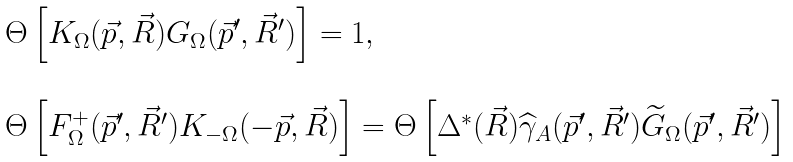<formula> <loc_0><loc_0><loc_500><loc_500>\begin{array} { l } \Theta \left [ K _ { \Omega } ( \vec { p } , \vec { R } ) G _ { \Omega } ( \vec { p } ^ { \prime } , \vec { R } ^ { \prime } ) \right ] = 1 , \\ \\ \Theta \left [ F ^ { + } _ { \Omega } ( \vec { p } ^ { \prime } , \vec { R } ^ { \prime } ) K _ { - \Omega } ( - \vec { p } , \vec { R } ) \right ] = \Theta \left [ \Delta ^ { * } ( \vec { R } ) \widehat { \gamma } _ { A } ( \vec { p } ^ { \prime } , \vec { R } ^ { \prime } ) \widetilde { G } _ { \Omega } ( \vec { p } ^ { \prime } , \vec { R } ^ { \prime } ) \right ] \end{array}</formula> 